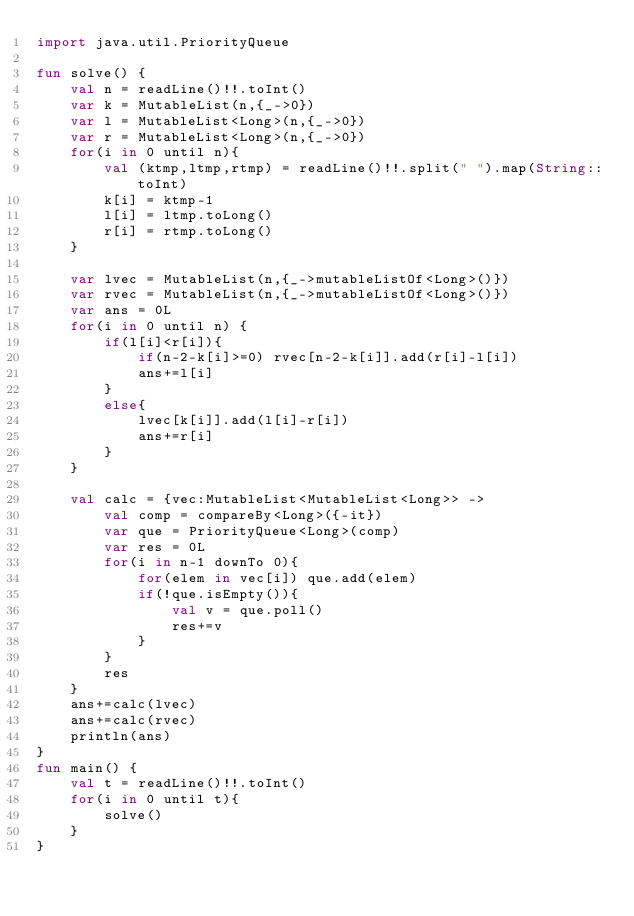<code> <loc_0><loc_0><loc_500><loc_500><_Kotlin_>import java.util.PriorityQueue

fun solve() {
    val n = readLine()!!.toInt()
    var k = MutableList(n,{_->0})    
    var l = MutableList<Long>(n,{_->0})    
    var r = MutableList<Long>(n,{_->0})    
    for(i in 0 until n){
        val (ktmp,ltmp,rtmp) = readLine()!!.split(" ").map(String::toInt)
        k[i] = ktmp-1
        l[i] = ltmp.toLong()
        r[i] = rtmp.toLong()
    }

    var lvec = MutableList(n,{_->mutableListOf<Long>()})
    var rvec = MutableList(n,{_->mutableListOf<Long>()})
    var ans = 0L
    for(i in 0 until n) {
        if(l[i]<r[i]){
            if(n-2-k[i]>=0) rvec[n-2-k[i]].add(r[i]-l[i])
            ans+=l[i]
        }
        else{
            lvec[k[i]].add(l[i]-r[i])
            ans+=r[i]
        }
    }

    val calc = {vec:MutableList<MutableList<Long>> ->
        val comp = compareBy<Long>({-it})
        var que = PriorityQueue<Long>(comp)
        var res = 0L
        for(i in n-1 downTo 0){
            for(elem in vec[i]) que.add(elem)
            if(!que.isEmpty()){
                val v = que.poll()
                res+=v
            }   
        }
        res
    }
    ans+=calc(lvec)
    ans+=calc(rvec)
    println(ans)
}
fun main() {
    val t = readLine()!!.toInt()
    for(i in 0 until t){
        solve()
    }
}
</code> 